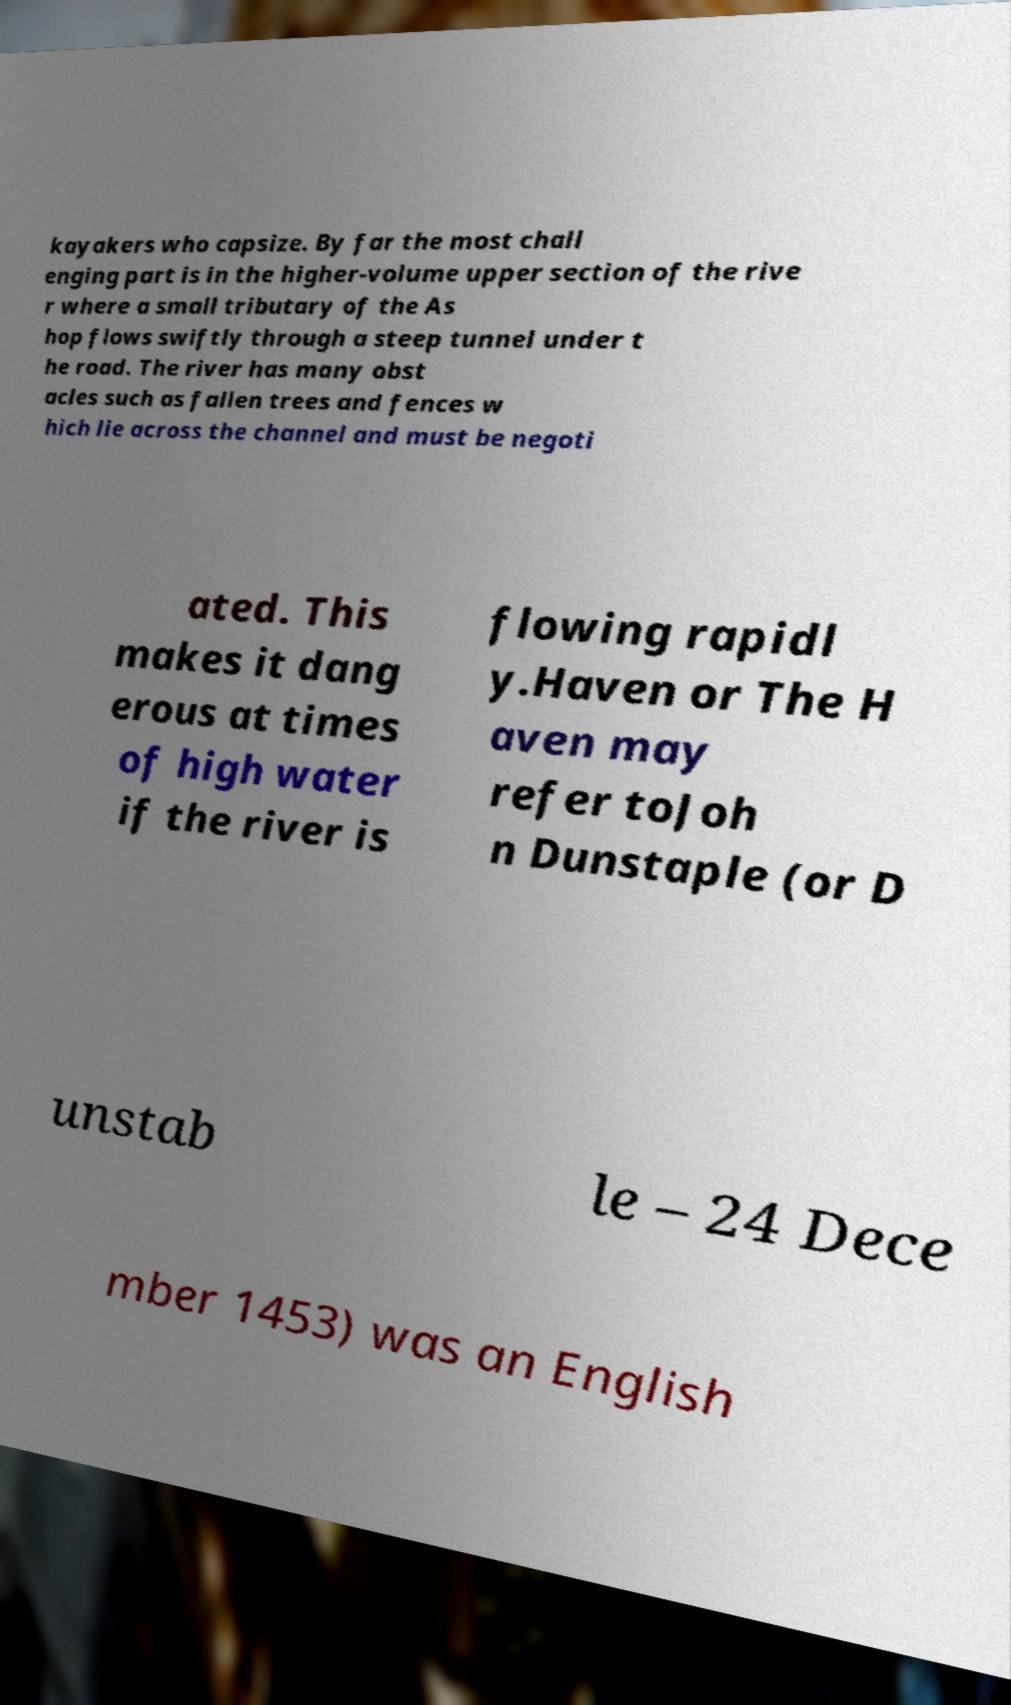Please identify and transcribe the text found in this image. kayakers who capsize. By far the most chall enging part is in the higher-volume upper section of the rive r where a small tributary of the As hop flows swiftly through a steep tunnel under t he road. The river has many obst acles such as fallen trees and fences w hich lie across the channel and must be negoti ated. This makes it dang erous at times of high water if the river is flowing rapidl y.Haven or The H aven may refer toJoh n Dunstaple (or D unstab le – 24 Dece mber 1453) was an English 